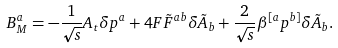<formula> <loc_0><loc_0><loc_500><loc_500>B _ { M } ^ { a } = - \frac { 1 } { \sqrt { s } } A _ { t } \delta p ^ { a } + 4 F \tilde { F } ^ { a b } \delta \tilde { A } _ { b } + \frac { 2 } { \sqrt { s } } \beta ^ { [ a } p ^ { b ] } \delta \tilde { A } _ { b } .</formula> 